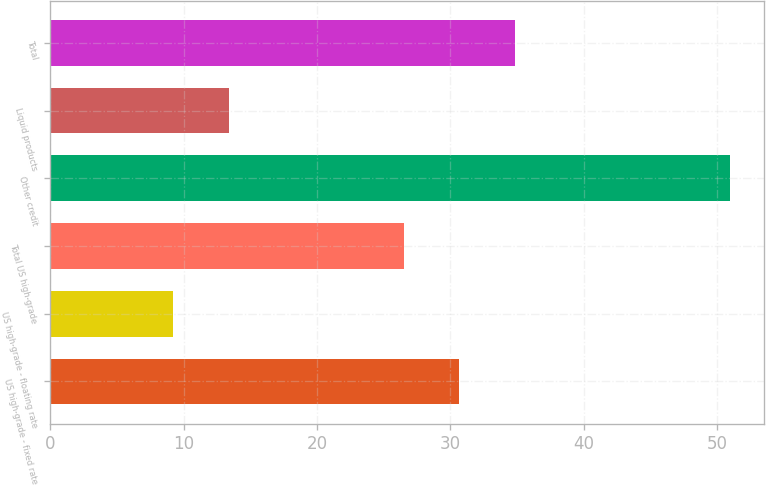<chart> <loc_0><loc_0><loc_500><loc_500><bar_chart><fcel>US high-grade - fixed rate<fcel>US high-grade - floating rate<fcel>Total US high-grade<fcel>Other credit<fcel>Liquid products<fcel>Total<nl><fcel>30.68<fcel>9.2<fcel>26.5<fcel>51<fcel>13.38<fcel>34.86<nl></chart> 